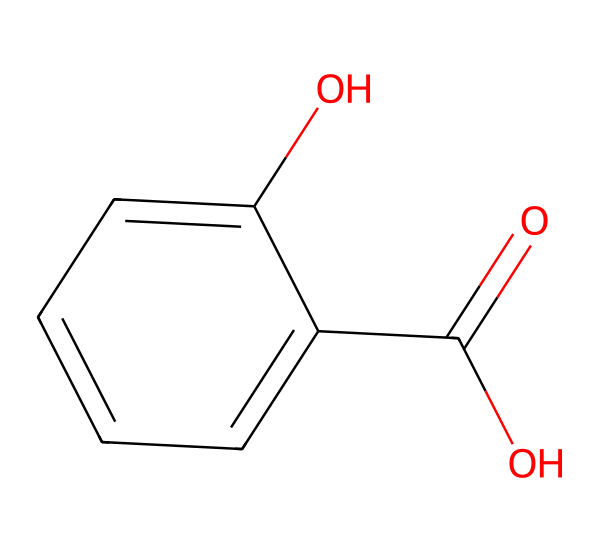What is the name of this chemical? The SMILES representation corresponds to a structure that includes a carboxylic acid group (-COOH) and a hydroxyl group (-OH) on a benzene ring, which is characteristic of salicylic acid.
Answer: salicylic acid How many carbon atoms are in salicylic acid? Counting the carbon atoms in the skeletal structure derived from the SMILES representation, there are seven carbons in total: six from the benzene ring and one from the carboxylic acid group.
Answer: 7 How many oxygen atoms are present in the structure? Examining the SMILES notation, there are two oxygen atoms noted: one from the carboxylic acid group and one from the hydroxyl group, so the total is two.
Answer: 2 What functional groups are present in salicylic acid? The structure displays two functional groups: a carboxylic acid group (-COOH) and a hydroxyl group (-OH), which are vital for its acidic properties.
Answer: carboxylic acid and hydroxyl What specific property of salicylic acid makes it effective in skincare? The presence of the carboxylic acid functional group allows salicylic acid to penetrate pores and exfoliate the skin, making it effective for treating acne.
Answer: exfoliation Which part of the molecule contributes to its acidity? The carboxylic acid group (-COOH) provides the hydrogen ion (H+) that dissociates, giving salicylic acid its acidic character.
Answer: carboxylic acid group Is salicylic acid soluble in water? The presence of the hydroxyl (-OH) and carboxylic acid (-COOH) groups increases the solubility of salicylic acid in water due to hydrogen bonding.
Answer: Yes 